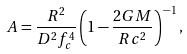<formula> <loc_0><loc_0><loc_500><loc_500>A = \frac { R ^ { 2 } } { D ^ { 2 } f _ { c } ^ { 4 } } \left ( 1 - \frac { 2 G M } { R c ^ { 2 } } \right ) ^ { - 1 } ,</formula> 